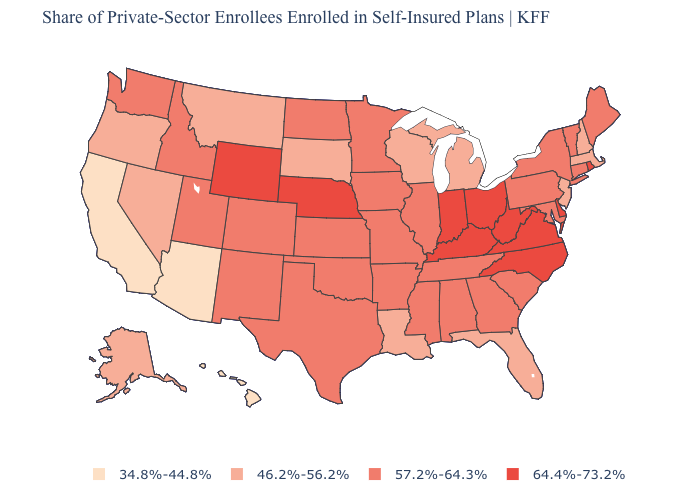Does Virginia have the highest value in the South?
Give a very brief answer. Yes. Does the first symbol in the legend represent the smallest category?
Short answer required. Yes. How many symbols are there in the legend?
Quick response, please. 4. Among the states that border Minnesota , which have the lowest value?
Answer briefly. South Dakota, Wisconsin. What is the value of Vermont?
Give a very brief answer. 57.2%-64.3%. Does Minnesota have a higher value than California?
Concise answer only. Yes. Does California have the lowest value in the USA?
Keep it brief. Yes. Name the states that have a value in the range 34.8%-44.8%?
Concise answer only. Arizona, California, Hawaii. Name the states that have a value in the range 64.4%-73.2%?
Concise answer only. Delaware, Indiana, Kentucky, Nebraska, North Carolina, Ohio, Rhode Island, Virginia, West Virginia, Wyoming. Which states have the lowest value in the USA?
Quick response, please. Arizona, California, Hawaii. Does Minnesota have a lower value than Virginia?
Give a very brief answer. Yes. What is the value of North Carolina?
Quick response, please. 64.4%-73.2%. Does Arizona have a lower value than Massachusetts?
Quick response, please. Yes. What is the lowest value in the USA?
Answer briefly. 34.8%-44.8%. What is the highest value in states that border Wisconsin?
Write a very short answer. 57.2%-64.3%. 